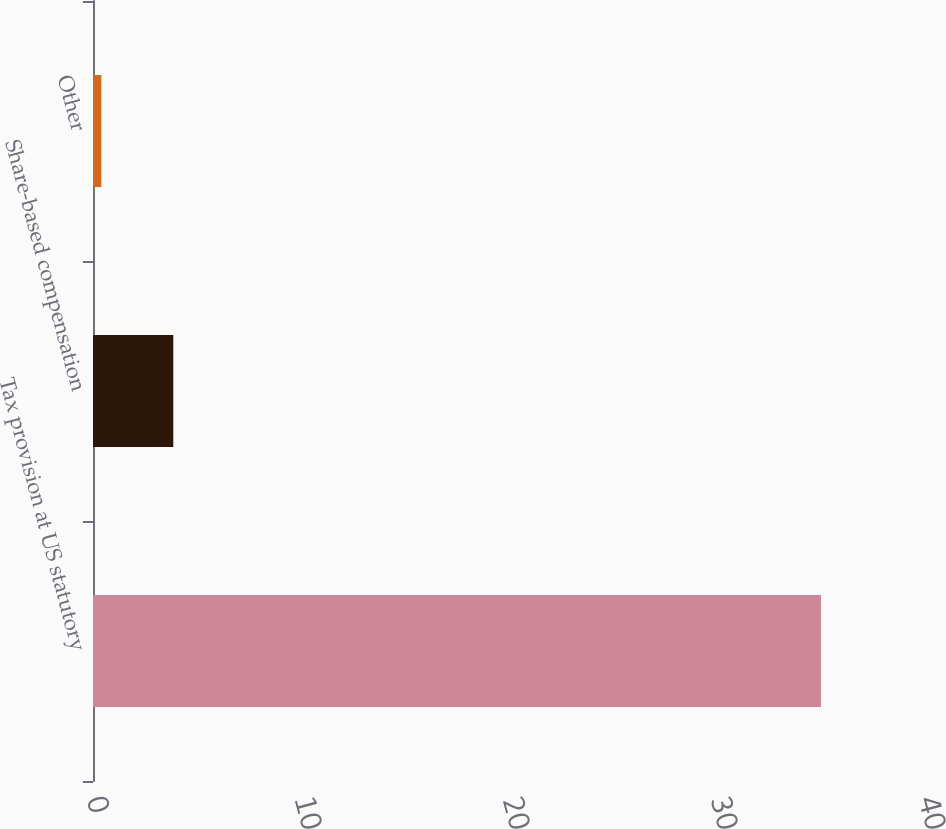Convert chart to OTSL. <chart><loc_0><loc_0><loc_500><loc_500><bar_chart><fcel>Tax provision at US statutory<fcel>Share-based compensation<fcel>Other<nl><fcel>35<fcel>3.86<fcel>0.4<nl></chart> 